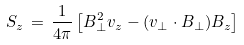Convert formula to latex. <formula><loc_0><loc_0><loc_500><loc_500>S _ { z } \, = \, \frac { 1 } { 4 \pi } \left [ B _ { \perp } ^ { 2 } v _ { z } - ( { v } _ { \perp } \cdot { B } _ { \perp } ) B _ { z } \right ]</formula> 